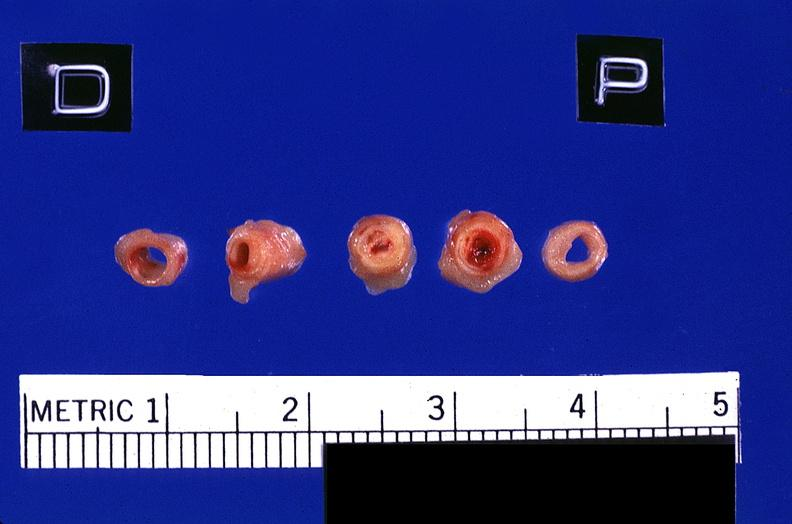s acid present?
Answer the question using a single word or phrase. No 